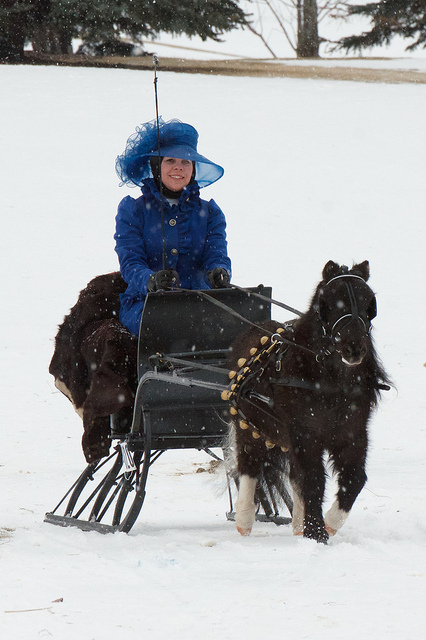Describe the vehicle the person is riding in. The person is seated on a traditional, simple sled known as a cutter, which is designed to glide over snow and is pulled by the pony. In what kind of events might you find this type of sled and pony? Such sleds and ponies can often be seen in winter festivals, holiday parades, or sleigh rallies, offering a nostalgic mode of transportation and entertainment. 